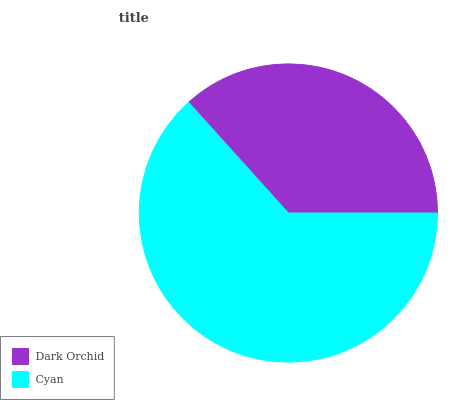Is Dark Orchid the minimum?
Answer yes or no. Yes. Is Cyan the maximum?
Answer yes or no. Yes. Is Cyan the minimum?
Answer yes or no. No. Is Cyan greater than Dark Orchid?
Answer yes or no. Yes. Is Dark Orchid less than Cyan?
Answer yes or no. Yes. Is Dark Orchid greater than Cyan?
Answer yes or no. No. Is Cyan less than Dark Orchid?
Answer yes or no. No. Is Cyan the high median?
Answer yes or no. Yes. Is Dark Orchid the low median?
Answer yes or no. Yes. Is Dark Orchid the high median?
Answer yes or no. No. Is Cyan the low median?
Answer yes or no. No. 